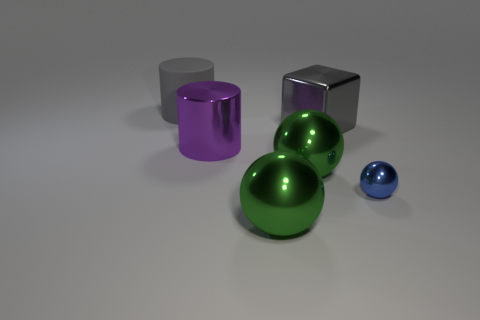Add 1 green shiny balls. How many objects exist? 7 Subtract all blocks. How many objects are left? 5 Subtract all large metallic spheres. Subtract all tiny shiny objects. How many objects are left? 3 Add 5 big green metal objects. How many big green metal objects are left? 7 Add 2 shiny blocks. How many shiny blocks exist? 3 Subtract 0 yellow balls. How many objects are left? 6 